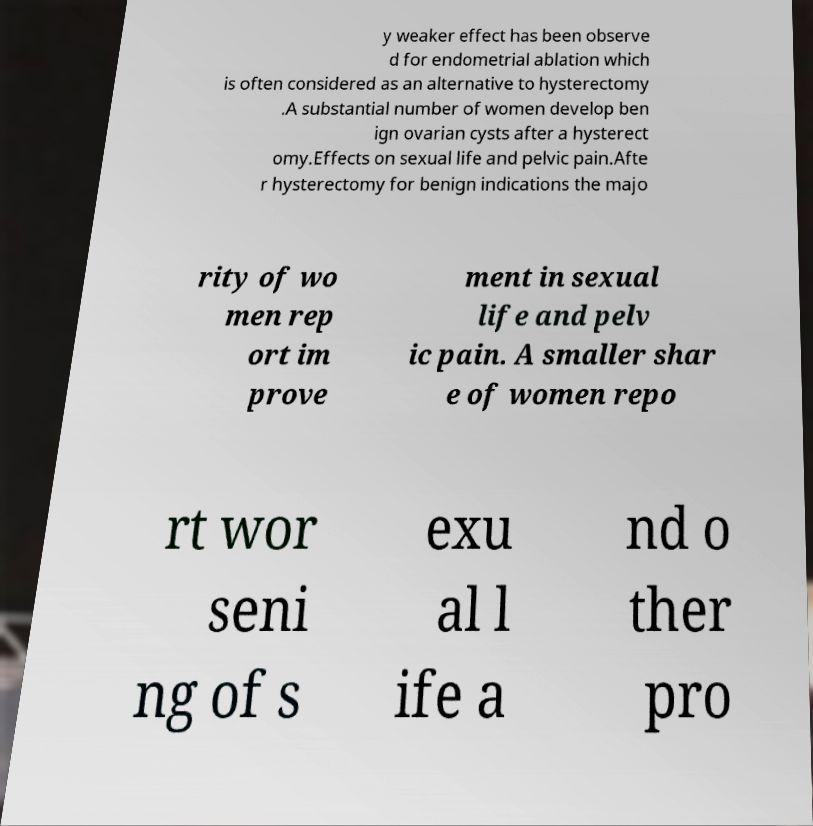What messages or text are displayed in this image? I need them in a readable, typed format. y weaker effect has been observe d for endometrial ablation which is often considered as an alternative to hysterectomy .A substantial number of women develop ben ign ovarian cysts after a hysterect omy.Effects on sexual life and pelvic pain.Afte r hysterectomy for benign indications the majo rity of wo men rep ort im prove ment in sexual life and pelv ic pain. A smaller shar e of women repo rt wor seni ng of s exu al l ife a nd o ther pro 